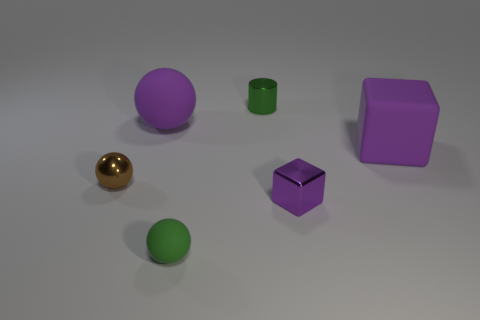What number of big objects are green balls or yellow things?
Give a very brief answer. 0. There is a metallic cylinder that is the same size as the purple metal block; what color is it?
Give a very brief answer. Green. How many brown balls are behind the big purple rubber sphere?
Offer a very short reply. 0. Are there any green cylinders that have the same material as the tiny brown sphere?
Provide a succinct answer. Yes. There is a big rubber thing that is the same color as the large block; what shape is it?
Provide a short and direct response. Sphere. The tiny metallic object that is to the right of the green metallic object is what color?
Offer a very short reply. Purple. Are there the same number of shiny cylinders in front of the tiny metal cylinder and balls that are in front of the tiny purple metal thing?
Your answer should be compact. No. What material is the small sphere on the right side of the purple object that is on the left side of the green matte sphere made of?
Ensure brevity in your answer.  Rubber. What number of things are small metal things or large purple matte things that are left of the small cylinder?
Your answer should be compact. 4. The green ball that is made of the same material as the big cube is what size?
Your response must be concise. Small. 